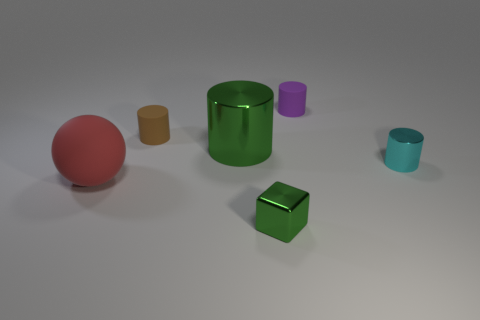How many metal things are brown cylinders or blue objects?
Your response must be concise. 0. Is there a tiny red ball made of the same material as the red object?
Ensure brevity in your answer.  No. What material is the large red ball?
Give a very brief answer. Rubber. The small matte object that is in front of the tiny cylinder that is behind the small rubber cylinder that is in front of the small purple cylinder is what shape?
Provide a succinct answer. Cylinder. Are there more tiny rubber things that are behind the cyan cylinder than cylinders?
Give a very brief answer. No. There is a small green object; is its shape the same as the small matte object that is to the right of the green cylinder?
Give a very brief answer. No. What shape is the large shiny object that is the same color as the shiny block?
Provide a succinct answer. Cylinder. There is a thing that is right of the rubber thing that is right of the metal cube; how many green objects are on the left side of it?
Your answer should be compact. 2. There is a metallic object that is the same size as the cyan metal cylinder; what color is it?
Offer a terse response. Green. What is the size of the shiny thing that is to the left of the shiny object in front of the red matte ball?
Offer a terse response. Large. 